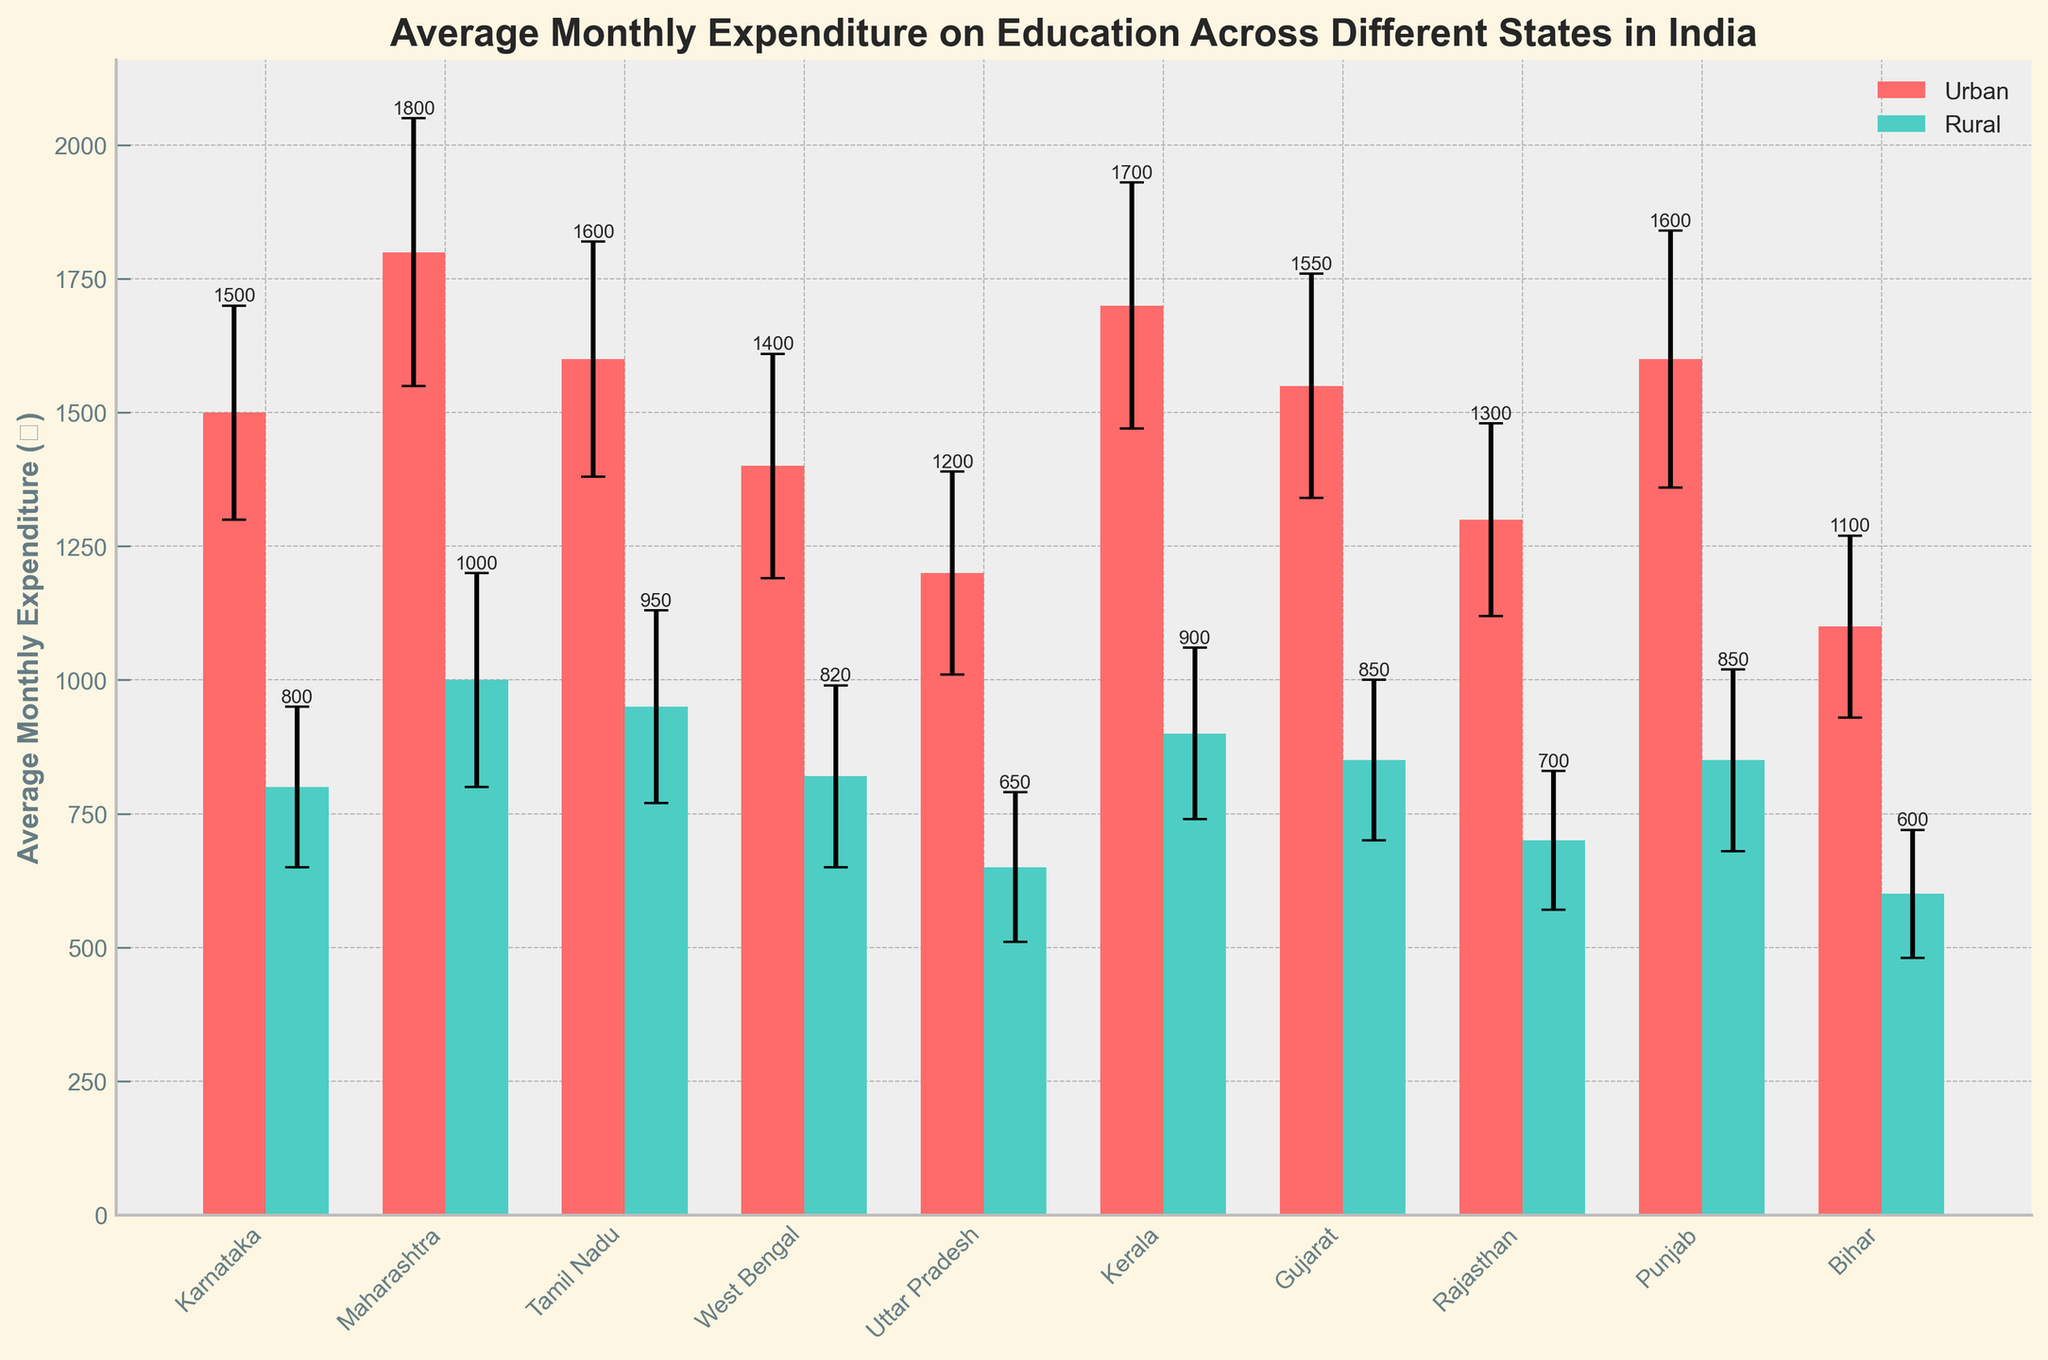What is the title of the figure? The title is usually displayed at the top of the figure, summarizing what the data represents.
Answer: Average Monthly Expenditure on Education Across Different States in India What is the average monthly expenditure on education for urban areas in Karnataka? The urban expenditure for Karnataka is represented by one of the bars labeled with the state name; finding the numerical value on the y-axis indicates the expenditure.
Answer: ₹1500 Which state has the highest average monthly expenditure for urban areas? Look for the tallest bar in the 'Urban' group, identified by the different colors representing urban areas.
Answer: Maharashtra In which state is the difference between urban and rural expenditure the smallest? Calculate the difference between urban and rural expenditures for each state, and identify the state with the smallest difference. For instance, Kerala has an urban expenditure of ₹1700 and a rural expenditure of ₹900, making the difference ₹800. Repeat for other states.
Answer: Rajasthan How do the standard deviations for urban expenditure compare between Karnataka and Maharashtra? Look at the error bars on top of the bars for Karnataka and Maharashtra in the 'Urban' group; Karnataka's error bar represents a standard deviation of ₹200, and Maharashtra's represents ₹250.
Answer: Maharashtra has a higher standard deviation for urban expenditure Which state has the lowest average rural expenditure, and what is the value? Identify the shortest bar in the 'Rural' group and find the corresponding state and numerical value.
Answer: Bihar, ₹600 By how much does the urban average expenditure in Maharashtra exceed the rural average expenditure in Kerala? The urban expenditure in Maharashtra (₹1800) minus the rural expenditure in Kerala (₹900). Calculate 1800 - 900.
Answer: ₹900 Which state shows the most variation in urban expenditure based on the standard deviation? The variation is shown by the length of the error bars; the state with the longest error bar in the 'Urban' group has the highest standard deviation.
Answer: Maharashtra What is the combined average expenditure for urban and rural areas in Tamil Nadu? Add the urban and rural expenditures for Tamil Nadu (₹1600 + ₹950 = ₹2550).
Answer: ₹2550 